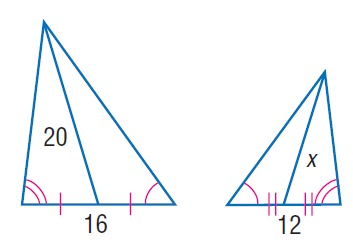Answer the mathemtical geometry problem and directly provide the correct option letter.
Question: Find x.
Choices: A: 10 B: 12 C: 15 D: 16 C 